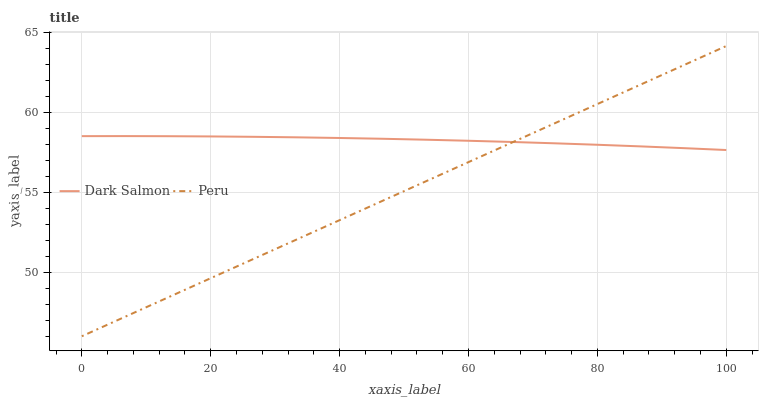Does Peru have the minimum area under the curve?
Answer yes or no. Yes. Does Dark Salmon have the maximum area under the curve?
Answer yes or no. Yes. Does Peru have the maximum area under the curve?
Answer yes or no. No. Is Peru the smoothest?
Answer yes or no. Yes. Is Dark Salmon the roughest?
Answer yes or no. Yes. Is Peru the roughest?
Answer yes or no. No. Does Peru have the lowest value?
Answer yes or no. Yes. Does Peru have the highest value?
Answer yes or no. Yes. Does Dark Salmon intersect Peru?
Answer yes or no. Yes. Is Dark Salmon less than Peru?
Answer yes or no. No. Is Dark Salmon greater than Peru?
Answer yes or no. No. 